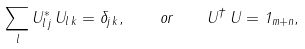<formula> <loc_0><loc_0><loc_500><loc_500>\sum _ { l } U ^ { * } _ { l \, j } \, U _ { l \, k } = \delta _ { j \, k } , \quad o r \quad U ^ { \dagger } \, U = 1 _ { m + n } ,</formula> 